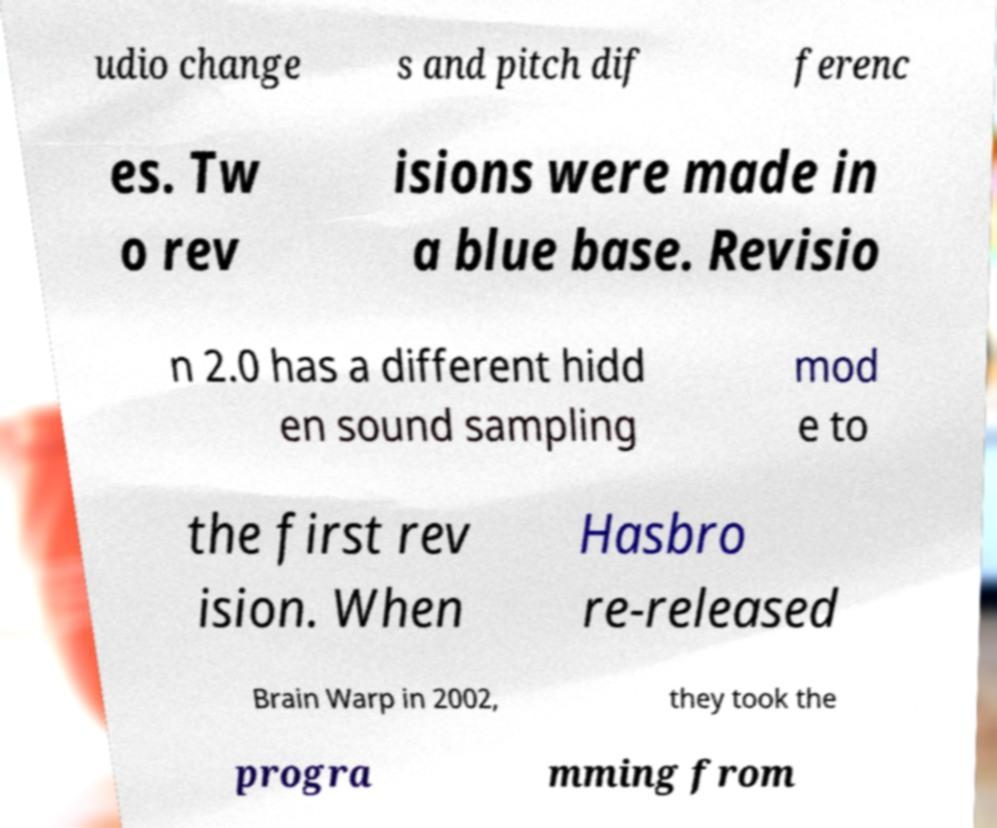What messages or text are displayed in this image? I need them in a readable, typed format. udio change s and pitch dif ferenc es. Tw o rev isions were made in a blue base. Revisio n 2.0 has a different hidd en sound sampling mod e to the first rev ision. When Hasbro re-released Brain Warp in 2002, they took the progra mming from 